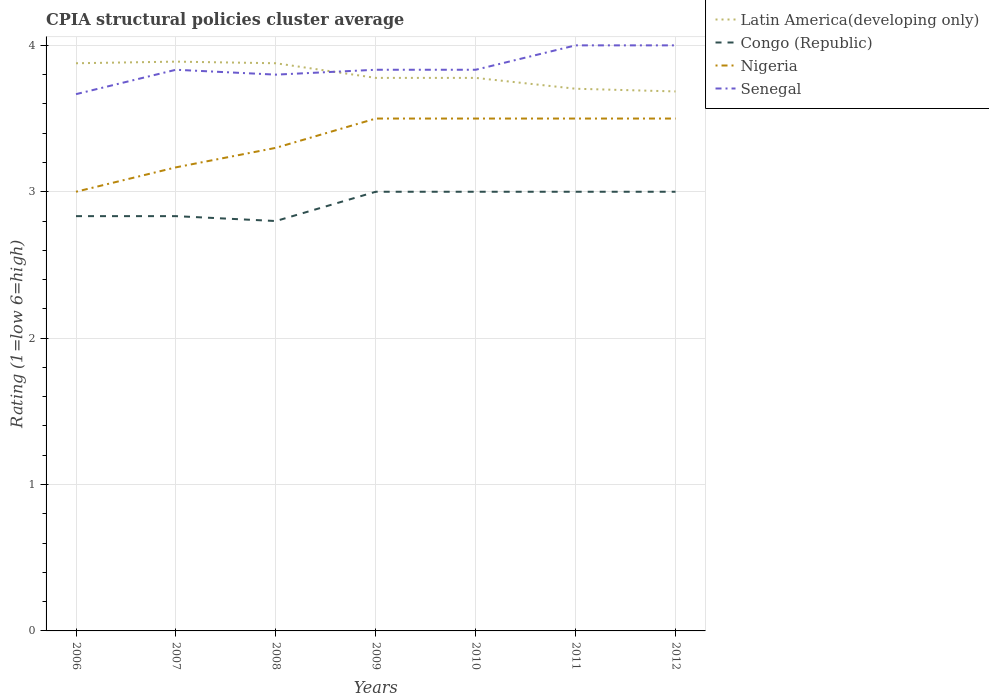How many different coloured lines are there?
Keep it short and to the point. 4. Is the number of lines equal to the number of legend labels?
Your response must be concise. Yes. In which year was the CPIA rating in Congo (Republic) maximum?
Your answer should be compact. 2008. What is the difference between the highest and the second highest CPIA rating in Nigeria?
Your response must be concise. 0.5. What is the difference between the highest and the lowest CPIA rating in Senegal?
Your answer should be very brief. 2. Is the CPIA rating in Senegal strictly greater than the CPIA rating in Nigeria over the years?
Your answer should be compact. No. How many lines are there?
Keep it short and to the point. 4. Does the graph contain any zero values?
Make the answer very short. No. Does the graph contain grids?
Offer a terse response. Yes. Where does the legend appear in the graph?
Keep it short and to the point. Top right. How are the legend labels stacked?
Your response must be concise. Vertical. What is the title of the graph?
Offer a very short reply. CPIA structural policies cluster average. Does "Estonia" appear as one of the legend labels in the graph?
Your response must be concise. No. What is the label or title of the X-axis?
Make the answer very short. Years. What is the label or title of the Y-axis?
Offer a very short reply. Rating (1=low 6=high). What is the Rating (1=low 6=high) of Latin America(developing only) in 2006?
Keep it short and to the point. 3.88. What is the Rating (1=low 6=high) of Congo (Republic) in 2006?
Offer a very short reply. 2.83. What is the Rating (1=low 6=high) of Nigeria in 2006?
Offer a very short reply. 3. What is the Rating (1=low 6=high) of Senegal in 2006?
Offer a terse response. 3.67. What is the Rating (1=low 6=high) of Latin America(developing only) in 2007?
Offer a terse response. 3.89. What is the Rating (1=low 6=high) in Congo (Republic) in 2007?
Offer a very short reply. 2.83. What is the Rating (1=low 6=high) of Nigeria in 2007?
Your response must be concise. 3.17. What is the Rating (1=low 6=high) in Senegal in 2007?
Offer a very short reply. 3.83. What is the Rating (1=low 6=high) of Latin America(developing only) in 2008?
Offer a terse response. 3.88. What is the Rating (1=low 6=high) of Nigeria in 2008?
Give a very brief answer. 3.3. What is the Rating (1=low 6=high) of Latin America(developing only) in 2009?
Provide a succinct answer. 3.78. What is the Rating (1=low 6=high) of Congo (Republic) in 2009?
Ensure brevity in your answer.  3. What is the Rating (1=low 6=high) of Nigeria in 2009?
Provide a short and direct response. 3.5. What is the Rating (1=low 6=high) in Senegal in 2009?
Your response must be concise. 3.83. What is the Rating (1=low 6=high) of Latin America(developing only) in 2010?
Ensure brevity in your answer.  3.78. What is the Rating (1=low 6=high) in Congo (Republic) in 2010?
Ensure brevity in your answer.  3. What is the Rating (1=low 6=high) in Senegal in 2010?
Make the answer very short. 3.83. What is the Rating (1=low 6=high) in Latin America(developing only) in 2011?
Your answer should be compact. 3.7. What is the Rating (1=low 6=high) in Latin America(developing only) in 2012?
Your answer should be compact. 3.69. What is the Rating (1=low 6=high) of Congo (Republic) in 2012?
Keep it short and to the point. 3. What is the Rating (1=low 6=high) in Nigeria in 2012?
Offer a very short reply. 3.5. What is the Rating (1=low 6=high) of Senegal in 2012?
Offer a very short reply. 4. Across all years, what is the maximum Rating (1=low 6=high) of Latin America(developing only)?
Your answer should be very brief. 3.89. Across all years, what is the maximum Rating (1=low 6=high) in Senegal?
Offer a very short reply. 4. Across all years, what is the minimum Rating (1=low 6=high) of Latin America(developing only)?
Your answer should be compact. 3.69. Across all years, what is the minimum Rating (1=low 6=high) of Congo (Republic)?
Your response must be concise. 2.8. Across all years, what is the minimum Rating (1=low 6=high) of Senegal?
Your answer should be very brief. 3.67. What is the total Rating (1=low 6=high) in Latin America(developing only) in the graph?
Make the answer very short. 26.59. What is the total Rating (1=low 6=high) in Congo (Republic) in the graph?
Give a very brief answer. 20.47. What is the total Rating (1=low 6=high) in Nigeria in the graph?
Ensure brevity in your answer.  23.47. What is the total Rating (1=low 6=high) of Senegal in the graph?
Offer a very short reply. 26.97. What is the difference between the Rating (1=low 6=high) of Latin America(developing only) in 2006 and that in 2007?
Keep it short and to the point. -0.01. What is the difference between the Rating (1=low 6=high) of Congo (Republic) in 2006 and that in 2008?
Offer a very short reply. 0.03. What is the difference between the Rating (1=low 6=high) in Nigeria in 2006 and that in 2008?
Your answer should be very brief. -0.3. What is the difference between the Rating (1=low 6=high) of Senegal in 2006 and that in 2008?
Give a very brief answer. -0.13. What is the difference between the Rating (1=low 6=high) in Nigeria in 2006 and that in 2009?
Offer a terse response. -0.5. What is the difference between the Rating (1=low 6=high) of Senegal in 2006 and that in 2009?
Make the answer very short. -0.17. What is the difference between the Rating (1=low 6=high) of Latin America(developing only) in 2006 and that in 2010?
Make the answer very short. 0.1. What is the difference between the Rating (1=low 6=high) in Nigeria in 2006 and that in 2010?
Provide a succinct answer. -0.5. What is the difference between the Rating (1=low 6=high) of Latin America(developing only) in 2006 and that in 2011?
Offer a very short reply. 0.17. What is the difference between the Rating (1=low 6=high) in Congo (Republic) in 2006 and that in 2011?
Keep it short and to the point. -0.17. What is the difference between the Rating (1=low 6=high) in Latin America(developing only) in 2006 and that in 2012?
Offer a very short reply. 0.19. What is the difference between the Rating (1=low 6=high) of Nigeria in 2006 and that in 2012?
Provide a succinct answer. -0.5. What is the difference between the Rating (1=low 6=high) of Latin America(developing only) in 2007 and that in 2008?
Keep it short and to the point. 0.01. What is the difference between the Rating (1=low 6=high) of Congo (Republic) in 2007 and that in 2008?
Ensure brevity in your answer.  0.03. What is the difference between the Rating (1=low 6=high) in Nigeria in 2007 and that in 2008?
Give a very brief answer. -0.13. What is the difference between the Rating (1=low 6=high) in Senegal in 2007 and that in 2008?
Offer a terse response. 0.03. What is the difference between the Rating (1=low 6=high) in Congo (Republic) in 2007 and that in 2009?
Ensure brevity in your answer.  -0.17. What is the difference between the Rating (1=low 6=high) of Nigeria in 2007 and that in 2009?
Keep it short and to the point. -0.33. What is the difference between the Rating (1=low 6=high) of Congo (Republic) in 2007 and that in 2010?
Your answer should be compact. -0.17. What is the difference between the Rating (1=low 6=high) of Latin America(developing only) in 2007 and that in 2011?
Your answer should be compact. 0.19. What is the difference between the Rating (1=low 6=high) in Congo (Republic) in 2007 and that in 2011?
Offer a very short reply. -0.17. What is the difference between the Rating (1=low 6=high) in Senegal in 2007 and that in 2011?
Offer a very short reply. -0.17. What is the difference between the Rating (1=low 6=high) in Latin America(developing only) in 2007 and that in 2012?
Your answer should be compact. 0.2. What is the difference between the Rating (1=low 6=high) of Congo (Republic) in 2007 and that in 2012?
Offer a terse response. -0.17. What is the difference between the Rating (1=low 6=high) of Congo (Republic) in 2008 and that in 2009?
Keep it short and to the point. -0.2. What is the difference between the Rating (1=low 6=high) of Senegal in 2008 and that in 2009?
Give a very brief answer. -0.03. What is the difference between the Rating (1=low 6=high) of Congo (Republic) in 2008 and that in 2010?
Give a very brief answer. -0.2. What is the difference between the Rating (1=low 6=high) in Nigeria in 2008 and that in 2010?
Give a very brief answer. -0.2. What is the difference between the Rating (1=low 6=high) in Senegal in 2008 and that in 2010?
Provide a short and direct response. -0.03. What is the difference between the Rating (1=low 6=high) of Latin America(developing only) in 2008 and that in 2011?
Offer a terse response. 0.17. What is the difference between the Rating (1=low 6=high) in Congo (Republic) in 2008 and that in 2011?
Ensure brevity in your answer.  -0.2. What is the difference between the Rating (1=low 6=high) of Latin America(developing only) in 2008 and that in 2012?
Offer a terse response. 0.19. What is the difference between the Rating (1=low 6=high) in Nigeria in 2008 and that in 2012?
Ensure brevity in your answer.  -0.2. What is the difference between the Rating (1=low 6=high) in Congo (Republic) in 2009 and that in 2010?
Ensure brevity in your answer.  0. What is the difference between the Rating (1=low 6=high) of Nigeria in 2009 and that in 2010?
Your answer should be compact. 0. What is the difference between the Rating (1=low 6=high) in Senegal in 2009 and that in 2010?
Provide a succinct answer. 0. What is the difference between the Rating (1=low 6=high) in Latin America(developing only) in 2009 and that in 2011?
Provide a succinct answer. 0.07. What is the difference between the Rating (1=low 6=high) in Congo (Republic) in 2009 and that in 2011?
Provide a short and direct response. 0. What is the difference between the Rating (1=low 6=high) in Nigeria in 2009 and that in 2011?
Your answer should be compact. 0. What is the difference between the Rating (1=low 6=high) in Latin America(developing only) in 2009 and that in 2012?
Offer a very short reply. 0.09. What is the difference between the Rating (1=low 6=high) in Congo (Republic) in 2009 and that in 2012?
Your response must be concise. 0. What is the difference between the Rating (1=low 6=high) of Nigeria in 2009 and that in 2012?
Offer a terse response. 0. What is the difference between the Rating (1=low 6=high) of Senegal in 2009 and that in 2012?
Your response must be concise. -0.17. What is the difference between the Rating (1=low 6=high) in Latin America(developing only) in 2010 and that in 2011?
Your response must be concise. 0.07. What is the difference between the Rating (1=low 6=high) of Congo (Republic) in 2010 and that in 2011?
Your answer should be compact. 0. What is the difference between the Rating (1=low 6=high) of Nigeria in 2010 and that in 2011?
Give a very brief answer. 0. What is the difference between the Rating (1=low 6=high) of Senegal in 2010 and that in 2011?
Your response must be concise. -0.17. What is the difference between the Rating (1=low 6=high) in Latin America(developing only) in 2010 and that in 2012?
Your answer should be compact. 0.09. What is the difference between the Rating (1=low 6=high) in Nigeria in 2010 and that in 2012?
Keep it short and to the point. 0. What is the difference between the Rating (1=low 6=high) of Senegal in 2010 and that in 2012?
Keep it short and to the point. -0.17. What is the difference between the Rating (1=low 6=high) of Latin America(developing only) in 2011 and that in 2012?
Provide a succinct answer. 0.02. What is the difference between the Rating (1=low 6=high) in Congo (Republic) in 2011 and that in 2012?
Your answer should be very brief. 0. What is the difference between the Rating (1=low 6=high) in Senegal in 2011 and that in 2012?
Your response must be concise. 0. What is the difference between the Rating (1=low 6=high) of Latin America(developing only) in 2006 and the Rating (1=low 6=high) of Congo (Republic) in 2007?
Make the answer very short. 1.04. What is the difference between the Rating (1=low 6=high) in Latin America(developing only) in 2006 and the Rating (1=low 6=high) in Nigeria in 2007?
Provide a short and direct response. 0.71. What is the difference between the Rating (1=low 6=high) in Latin America(developing only) in 2006 and the Rating (1=low 6=high) in Senegal in 2007?
Ensure brevity in your answer.  0.04. What is the difference between the Rating (1=low 6=high) in Congo (Republic) in 2006 and the Rating (1=low 6=high) in Senegal in 2007?
Your answer should be compact. -1. What is the difference between the Rating (1=low 6=high) in Latin America(developing only) in 2006 and the Rating (1=low 6=high) in Congo (Republic) in 2008?
Provide a succinct answer. 1.08. What is the difference between the Rating (1=low 6=high) of Latin America(developing only) in 2006 and the Rating (1=low 6=high) of Nigeria in 2008?
Your answer should be compact. 0.58. What is the difference between the Rating (1=low 6=high) in Latin America(developing only) in 2006 and the Rating (1=low 6=high) in Senegal in 2008?
Offer a very short reply. 0.08. What is the difference between the Rating (1=low 6=high) in Congo (Republic) in 2006 and the Rating (1=low 6=high) in Nigeria in 2008?
Make the answer very short. -0.47. What is the difference between the Rating (1=low 6=high) in Congo (Republic) in 2006 and the Rating (1=low 6=high) in Senegal in 2008?
Your answer should be compact. -0.97. What is the difference between the Rating (1=low 6=high) of Nigeria in 2006 and the Rating (1=low 6=high) of Senegal in 2008?
Your answer should be compact. -0.8. What is the difference between the Rating (1=low 6=high) in Latin America(developing only) in 2006 and the Rating (1=low 6=high) in Congo (Republic) in 2009?
Offer a terse response. 0.88. What is the difference between the Rating (1=low 6=high) in Latin America(developing only) in 2006 and the Rating (1=low 6=high) in Nigeria in 2009?
Offer a very short reply. 0.38. What is the difference between the Rating (1=low 6=high) in Latin America(developing only) in 2006 and the Rating (1=low 6=high) in Senegal in 2009?
Give a very brief answer. 0.04. What is the difference between the Rating (1=low 6=high) in Nigeria in 2006 and the Rating (1=low 6=high) in Senegal in 2009?
Provide a short and direct response. -0.83. What is the difference between the Rating (1=low 6=high) of Latin America(developing only) in 2006 and the Rating (1=low 6=high) of Congo (Republic) in 2010?
Keep it short and to the point. 0.88. What is the difference between the Rating (1=low 6=high) of Latin America(developing only) in 2006 and the Rating (1=low 6=high) of Nigeria in 2010?
Give a very brief answer. 0.38. What is the difference between the Rating (1=low 6=high) of Latin America(developing only) in 2006 and the Rating (1=low 6=high) of Senegal in 2010?
Make the answer very short. 0.04. What is the difference between the Rating (1=low 6=high) in Congo (Republic) in 2006 and the Rating (1=low 6=high) in Senegal in 2010?
Offer a terse response. -1. What is the difference between the Rating (1=low 6=high) in Nigeria in 2006 and the Rating (1=low 6=high) in Senegal in 2010?
Offer a terse response. -0.83. What is the difference between the Rating (1=low 6=high) of Latin America(developing only) in 2006 and the Rating (1=low 6=high) of Congo (Republic) in 2011?
Ensure brevity in your answer.  0.88. What is the difference between the Rating (1=low 6=high) in Latin America(developing only) in 2006 and the Rating (1=low 6=high) in Nigeria in 2011?
Keep it short and to the point. 0.38. What is the difference between the Rating (1=low 6=high) of Latin America(developing only) in 2006 and the Rating (1=low 6=high) of Senegal in 2011?
Your answer should be compact. -0.12. What is the difference between the Rating (1=low 6=high) of Congo (Republic) in 2006 and the Rating (1=low 6=high) of Senegal in 2011?
Provide a succinct answer. -1.17. What is the difference between the Rating (1=low 6=high) of Latin America(developing only) in 2006 and the Rating (1=low 6=high) of Congo (Republic) in 2012?
Provide a short and direct response. 0.88. What is the difference between the Rating (1=low 6=high) of Latin America(developing only) in 2006 and the Rating (1=low 6=high) of Nigeria in 2012?
Your response must be concise. 0.38. What is the difference between the Rating (1=low 6=high) in Latin America(developing only) in 2006 and the Rating (1=low 6=high) in Senegal in 2012?
Make the answer very short. -0.12. What is the difference between the Rating (1=low 6=high) of Congo (Republic) in 2006 and the Rating (1=low 6=high) of Senegal in 2012?
Keep it short and to the point. -1.17. What is the difference between the Rating (1=low 6=high) in Nigeria in 2006 and the Rating (1=low 6=high) in Senegal in 2012?
Ensure brevity in your answer.  -1. What is the difference between the Rating (1=low 6=high) in Latin America(developing only) in 2007 and the Rating (1=low 6=high) in Congo (Republic) in 2008?
Provide a short and direct response. 1.09. What is the difference between the Rating (1=low 6=high) of Latin America(developing only) in 2007 and the Rating (1=low 6=high) of Nigeria in 2008?
Ensure brevity in your answer.  0.59. What is the difference between the Rating (1=low 6=high) of Latin America(developing only) in 2007 and the Rating (1=low 6=high) of Senegal in 2008?
Make the answer very short. 0.09. What is the difference between the Rating (1=low 6=high) of Congo (Republic) in 2007 and the Rating (1=low 6=high) of Nigeria in 2008?
Your answer should be very brief. -0.47. What is the difference between the Rating (1=low 6=high) of Congo (Republic) in 2007 and the Rating (1=low 6=high) of Senegal in 2008?
Make the answer very short. -0.97. What is the difference between the Rating (1=low 6=high) of Nigeria in 2007 and the Rating (1=low 6=high) of Senegal in 2008?
Ensure brevity in your answer.  -0.63. What is the difference between the Rating (1=low 6=high) in Latin America(developing only) in 2007 and the Rating (1=low 6=high) in Congo (Republic) in 2009?
Make the answer very short. 0.89. What is the difference between the Rating (1=low 6=high) in Latin America(developing only) in 2007 and the Rating (1=low 6=high) in Nigeria in 2009?
Your answer should be compact. 0.39. What is the difference between the Rating (1=low 6=high) in Latin America(developing only) in 2007 and the Rating (1=low 6=high) in Senegal in 2009?
Give a very brief answer. 0.06. What is the difference between the Rating (1=low 6=high) of Latin America(developing only) in 2007 and the Rating (1=low 6=high) of Nigeria in 2010?
Provide a succinct answer. 0.39. What is the difference between the Rating (1=low 6=high) in Latin America(developing only) in 2007 and the Rating (1=low 6=high) in Senegal in 2010?
Ensure brevity in your answer.  0.06. What is the difference between the Rating (1=low 6=high) of Congo (Republic) in 2007 and the Rating (1=low 6=high) of Nigeria in 2010?
Keep it short and to the point. -0.67. What is the difference between the Rating (1=low 6=high) in Congo (Republic) in 2007 and the Rating (1=low 6=high) in Senegal in 2010?
Make the answer very short. -1. What is the difference between the Rating (1=low 6=high) of Latin America(developing only) in 2007 and the Rating (1=low 6=high) of Congo (Republic) in 2011?
Make the answer very short. 0.89. What is the difference between the Rating (1=low 6=high) in Latin America(developing only) in 2007 and the Rating (1=low 6=high) in Nigeria in 2011?
Keep it short and to the point. 0.39. What is the difference between the Rating (1=low 6=high) in Latin America(developing only) in 2007 and the Rating (1=low 6=high) in Senegal in 2011?
Make the answer very short. -0.11. What is the difference between the Rating (1=low 6=high) in Congo (Republic) in 2007 and the Rating (1=low 6=high) in Senegal in 2011?
Your response must be concise. -1.17. What is the difference between the Rating (1=low 6=high) of Nigeria in 2007 and the Rating (1=low 6=high) of Senegal in 2011?
Provide a short and direct response. -0.83. What is the difference between the Rating (1=low 6=high) of Latin America(developing only) in 2007 and the Rating (1=low 6=high) of Nigeria in 2012?
Your response must be concise. 0.39. What is the difference between the Rating (1=low 6=high) of Latin America(developing only) in 2007 and the Rating (1=low 6=high) of Senegal in 2012?
Make the answer very short. -0.11. What is the difference between the Rating (1=low 6=high) of Congo (Republic) in 2007 and the Rating (1=low 6=high) of Senegal in 2012?
Make the answer very short. -1.17. What is the difference between the Rating (1=low 6=high) in Latin America(developing only) in 2008 and the Rating (1=low 6=high) in Congo (Republic) in 2009?
Provide a short and direct response. 0.88. What is the difference between the Rating (1=low 6=high) in Latin America(developing only) in 2008 and the Rating (1=low 6=high) in Nigeria in 2009?
Make the answer very short. 0.38. What is the difference between the Rating (1=low 6=high) in Latin America(developing only) in 2008 and the Rating (1=low 6=high) in Senegal in 2009?
Provide a short and direct response. 0.04. What is the difference between the Rating (1=low 6=high) in Congo (Republic) in 2008 and the Rating (1=low 6=high) in Senegal in 2009?
Make the answer very short. -1.03. What is the difference between the Rating (1=low 6=high) in Nigeria in 2008 and the Rating (1=low 6=high) in Senegal in 2009?
Provide a short and direct response. -0.53. What is the difference between the Rating (1=low 6=high) of Latin America(developing only) in 2008 and the Rating (1=low 6=high) of Congo (Republic) in 2010?
Make the answer very short. 0.88. What is the difference between the Rating (1=low 6=high) of Latin America(developing only) in 2008 and the Rating (1=low 6=high) of Nigeria in 2010?
Your answer should be compact. 0.38. What is the difference between the Rating (1=low 6=high) in Latin America(developing only) in 2008 and the Rating (1=low 6=high) in Senegal in 2010?
Make the answer very short. 0.04. What is the difference between the Rating (1=low 6=high) in Congo (Republic) in 2008 and the Rating (1=low 6=high) in Nigeria in 2010?
Ensure brevity in your answer.  -0.7. What is the difference between the Rating (1=low 6=high) in Congo (Republic) in 2008 and the Rating (1=low 6=high) in Senegal in 2010?
Your response must be concise. -1.03. What is the difference between the Rating (1=low 6=high) in Nigeria in 2008 and the Rating (1=low 6=high) in Senegal in 2010?
Provide a short and direct response. -0.53. What is the difference between the Rating (1=low 6=high) of Latin America(developing only) in 2008 and the Rating (1=low 6=high) of Congo (Republic) in 2011?
Keep it short and to the point. 0.88. What is the difference between the Rating (1=low 6=high) in Latin America(developing only) in 2008 and the Rating (1=low 6=high) in Nigeria in 2011?
Offer a very short reply. 0.38. What is the difference between the Rating (1=low 6=high) in Latin America(developing only) in 2008 and the Rating (1=low 6=high) in Senegal in 2011?
Offer a terse response. -0.12. What is the difference between the Rating (1=low 6=high) in Congo (Republic) in 2008 and the Rating (1=low 6=high) in Senegal in 2011?
Your answer should be very brief. -1.2. What is the difference between the Rating (1=low 6=high) in Nigeria in 2008 and the Rating (1=low 6=high) in Senegal in 2011?
Provide a short and direct response. -0.7. What is the difference between the Rating (1=low 6=high) of Latin America(developing only) in 2008 and the Rating (1=low 6=high) of Congo (Republic) in 2012?
Provide a succinct answer. 0.88. What is the difference between the Rating (1=low 6=high) in Latin America(developing only) in 2008 and the Rating (1=low 6=high) in Nigeria in 2012?
Your answer should be compact. 0.38. What is the difference between the Rating (1=low 6=high) in Latin America(developing only) in 2008 and the Rating (1=low 6=high) in Senegal in 2012?
Make the answer very short. -0.12. What is the difference between the Rating (1=low 6=high) of Congo (Republic) in 2008 and the Rating (1=low 6=high) of Nigeria in 2012?
Your answer should be compact. -0.7. What is the difference between the Rating (1=low 6=high) in Congo (Republic) in 2008 and the Rating (1=low 6=high) in Senegal in 2012?
Your response must be concise. -1.2. What is the difference between the Rating (1=low 6=high) of Nigeria in 2008 and the Rating (1=low 6=high) of Senegal in 2012?
Provide a succinct answer. -0.7. What is the difference between the Rating (1=low 6=high) in Latin America(developing only) in 2009 and the Rating (1=low 6=high) in Nigeria in 2010?
Offer a terse response. 0.28. What is the difference between the Rating (1=low 6=high) in Latin America(developing only) in 2009 and the Rating (1=low 6=high) in Senegal in 2010?
Provide a short and direct response. -0.06. What is the difference between the Rating (1=low 6=high) in Congo (Republic) in 2009 and the Rating (1=low 6=high) in Senegal in 2010?
Your answer should be very brief. -0.83. What is the difference between the Rating (1=low 6=high) of Latin America(developing only) in 2009 and the Rating (1=low 6=high) of Congo (Republic) in 2011?
Make the answer very short. 0.78. What is the difference between the Rating (1=low 6=high) in Latin America(developing only) in 2009 and the Rating (1=low 6=high) in Nigeria in 2011?
Offer a terse response. 0.28. What is the difference between the Rating (1=low 6=high) in Latin America(developing only) in 2009 and the Rating (1=low 6=high) in Senegal in 2011?
Give a very brief answer. -0.22. What is the difference between the Rating (1=low 6=high) in Congo (Republic) in 2009 and the Rating (1=low 6=high) in Senegal in 2011?
Your answer should be compact. -1. What is the difference between the Rating (1=low 6=high) in Latin America(developing only) in 2009 and the Rating (1=low 6=high) in Congo (Republic) in 2012?
Ensure brevity in your answer.  0.78. What is the difference between the Rating (1=low 6=high) of Latin America(developing only) in 2009 and the Rating (1=low 6=high) of Nigeria in 2012?
Provide a succinct answer. 0.28. What is the difference between the Rating (1=low 6=high) in Latin America(developing only) in 2009 and the Rating (1=low 6=high) in Senegal in 2012?
Give a very brief answer. -0.22. What is the difference between the Rating (1=low 6=high) in Congo (Republic) in 2009 and the Rating (1=low 6=high) in Senegal in 2012?
Make the answer very short. -1. What is the difference between the Rating (1=low 6=high) of Latin America(developing only) in 2010 and the Rating (1=low 6=high) of Nigeria in 2011?
Offer a terse response. 0.28. What is the difference between the Rating (1=low 6=high) of Latin America(developing only) in 2010 and the Rating (1=low 6=high) of Senegal in 2011?
Your answer should be very brief. -0.22. What is the difference between the Rating (1=low 6=high) of Latin America(developing only) in 2010 and the Rating (1=low 6=high) of Congo (Republic) in 2012?
Provide a short and direct response. 0.78. What is the difference between the Rating (1=low 6=high) of Latin America(developing only) in 2010 and the Rating (1=low 6=high) of Nigeria in 2012?
Offer a terse response. 0.28. What is the difference between the Rating (1=low 6=high) in Latin America(developing only) in 2010 and the Rating (1=low 6=high) in Senegal in 2012?
Your answer should be compact. -0.22. What is the difference between the Rating (1=low 6=high) of Congo (Republic) in 2010 and the Rating (1=low 6=high) of Nigeria in 2012?
Your response must be concise. -0.5. What is the difference between the Rating (1=low 6=high) in Nigeria in 2010 and the Rating (1=low 6=high) in Senegal in 2012?
Your answer should be very brief. -0.5. What is the difference between the Rating (1=low 6=high) in Latin America(developing only) in 2011 and the Rating (1=low 6=high) in Congo (Republic) in 2012?
Give a very brief answer. 0.7. What is the difference between the Rating (1=low 6=high) in Latin America(developing only) in 2011 and the Rating (1=low 6=high) in Nigeria in 2012?
Give a very brief answer. 0.2. What is the difference between the Rating (1=low 6=high) of Latin America(developing only) in 2011 and the Rating (1=low 6=high) of Senegal in 2012?
Your answer should be very brief. -0.3. What is the difference between the Rating (1=low 6=high) of Congo (Republic) in 2011 and the Rating (1=low 6=high) of Nigeria in 2012?
Your answer should be very brief. -0.5. What is the average Rating (1=low 6=high) of Latin America(developing only) per year?
Your answer should be very brief. 3.8. What is the average Rating (1=low 6=high) in Congo (Republic) per year?
Provide a short and direct response. 2.92. What is the average Rating (1=low 6=high) of Nigeria per year?
Ensure brevity in your answer.  3.35. What is the average Rating (1=low 6=high) of Senegal per year?
Provide a short and direct response. 3.85. In the year 2006, what is the difference between the Rating (1=low 6=high) of Latin America(developing only) and Rating (1=low 6=high) of Congo (Republic)?
Provide a succinct answer. 1.04. In the year 2006, what is the difference between the Rating (1=low 6=high) in Latin America(developing only) and Rating (1=low 6=high) in Nigeria?
Offer a terse response. 0.88. In the year 2006, what is the difference between the Rating (1=low 6=high) of Latin America(developing only) and Rating (1=low 6=high) of Senegal?
Provide a succinct answer. 0.21. In the year 2006, what is the difference between the Rating (1=low 6=high) of Congo (Republic) and Rating (1=low 6=high) of Nigeria?
Your answer should be compact. -0.17. In the year 2007, what is the difference between the Rating (1=low 6=high) of Latin America(developing only) and Rating (1=low 6=high) of Congo (Republic)?
Provide a succinct answer. 1.06. In the year 2007, what is the difference between the Rating (1=low 6=high) of Latin America(developing only) and Rating (1=low 6=high) of Nigeria?
Provide a short and direct response. 0.72. In the year 2007, what is the difference between the Rating (1=low 6=high) of Latin America(developing only) and Rating (1=low 6=high) of Senegal?
Give a very brief answer. 0.06. In the year 2007, what is the difference between the Rating (1=low 6=high) in Nigeria and Rating (1=low 6=high) in Senegal?
Offer a terse response. -0.67. In the year 2008, what is the difference between the Rating (1=low 6=high) of Latin America(developing only) and Rating (1=low 6=high) of Congo (Republic)?
Make the answer very short. 1.08. In the year 2008, what is the difference between the Rating (1=low 6=high) in Latin America(developing only) and Rating (1=low 6=high) in Nigeria?
Provide a succinct answer. 0.58. In the year 2008, what is the difference between the Rating (1=low 6=high) of Latin America(developing only) and Rating (1=low 6=high) of Senegal?
Provide a short and direct response. 0.08. In the year 2008, what is the difference between the Rating (1=low 6=high) of Nigeria and Rating (1=low 6=high) of Senegal?
Your answer should be very brief. -0.5. In the year 2009, what is the difference between the Rating (1=low 6=high) in Latin America(developing only) and Rating (1=low 6=high) in Congo (Republic)?
Your answer should be very brief. 0.78. In the year 2009, what is the difference between the Rating (1=low 6=high) in Latin America(developing only) and Rating (1=low 6=high) in Nigeria?
Provide a short and direct response. 0.28. In the year 2009, what is the difference between the Rating (1=low 6=high) of Latin America(developing only) and Rating (1=low 6=high) of Senegal?
Provide a succinct answer. -0.06. In the year 2009, what is the difference between the Rating (1=low 6=high) in Congo (Republic) and Rating (1=low 6=high) in Senegal?
Ensure brevity in your answer.  -0.83. In the year 2010, what is the difference between the Rating (1=low 6=high) of Latin America(developing only) and Rating (1=low 6=high) of Congo (Republic)?
Offer a very short reply. 0.78. In the year 2010, what is the difference between the Rating (1=low 6=high) in Latin America(developing only) and Rating (1=low 6=high) in Nigeria?
Provide a short and direct response. 0.28. In the year 2010, what is the difference between the Rating (1=low 6=high) of Latin America(developing only) and Rating (1=low 6=high) of Senegal?
Offer a terse response. -0.06. In the year 2010, what is the difference between the Rating (1=low 6=high) of Congo (Republic) and Rating (1=low 6=high) of Nigeria?
Make the answer very short. -0.5. In the year 2010, what is the difference between the Rating (1=low 6=high) of Congo (Republic) and Rating (1=low 6=high) of Senegal?
Offer a terse response. -0.83. In the year 2011, what is the difference between the Rating (1=low 6=high) of Latin America(developing only) and Rating (1=low 6=high) of Congo (Republic)?
Ensure brevity in your answer.  0.7. In the year 2011, what is the difference between the Rating (1=low 6=high) of Latin America(developing only) and Rating (1=low 6=high) of Nigeria?
Your answer should be compact. 0.2. In the year 2011, what is the difference between the Rating (1=low 6=high) of Latin America(developing only) and Rating (1=low 6=high) of Senegal?
Make the answer very short. -0.3. In the year 2012, what is the difference between the Rating (1=low 6=high) of Latin America(developing only) and Rating (1=low 6=high) of Congo (Republic)?
Your answer should be very brief. 0.69. In the year 2012, what is the difference between the Rating (1=low 6=high) in Latin America(developing only) and Rating (1=low 6=high) in Nigeria?
Provide a succinct answer. 0.19. In the year 2012, what is the difference between the Rating (1=low 6=high) of Latin America(developing only) and Rating (1=low 6=high) of Senegal?
Your answer should be very brief. -0.31. What is the ratio of the Rating (1=low 6=high) in Latin America(developing only) in 2006 to that in 2007?
Make the answer very short. 1. What is the ratio of the Rating (1=low 6=high) in Senegal in 2006 to that in 2007?
Offer a terse response. 0.96. What is the ratio of the Rating (1=low 6=high) of Latin America(developing only) in 2006 to that in 2008?
Make the answer very short. 1. What is the ratio of the Rating (1=low 6=high) of Congo (Republic) in 2006 to that in 2008?
Give a very brief answer. 1.01. What is the ratio of the Rating (1=low 6=high) in Nigeria in 2006 to that in 2008?
Make the answer very short. 0.91. What is the ratio of the Rating (1=low 6=high) in Senegal in 2006 to that in 2008?
Ensure brevity in your answer.  0.96. What is the ratio of the Rating (1=low 6=high) in Latin America(developing only) in 2006 to that in 2009?
Keep it short and to the point. 1.03. What is the ratio of the Rating (1=low 6=high) in Senegal in 2006 to that in 2009?
Your answer should be compact. 0.96. What is the ratio of the Rating (1=low 6=high) in Latin America(developing only) in 2006 to that in 2010?
Give a very brief answer. 1.03. What is the ratio of the Rating (1=low 6=high) in Congo (Republic) in 2006 to that in 2010?
Keep it short and to the point. 0.94. What is the ratio of the Rating (1=low 6=high) of Senegal in 2006 to that in 2010?
Your answer should be very brief. 0.96. What is the ratio of the Rating (1=low 6=high) in Latin America(developing only) in 2006 to that in 2011?
Provide a short and direct response. 1.05. What is the ratio of the Rating (1=low 6=high) in Congo (Republic) in 2006 to that in 2011?
Ensure brevity in your answer.  0.94. What is the ratio of the Rating (1=low 6=high) of Senegal in 2006 to that in 2011?
Your answer should be compact. 0.92. What is the ratio of the Rating (1=low 6=high) of Latin America(developing only) in 2006 to that in 2012?
Provide a succinct answer. 1.05. What is the ratio of the Rating (1=low 6=high) in Latin America(developing only) in 2007 to that in 2008?
Ensure brevity in your answer.  1. What is the ratio of the Rating (1=low 6=high) of Congo (Republic) in 2007 to that in 2008?
Offer a very short reply. 1.01. What is the ratio of the Rating (1=low 6=high) of Nigeria in 2007 to that in 2008?
Your answer should be very brief. 0.96. What is the ratio of the Rating (1=low 6=high) of Senegal in 2007 to that in 2008?
Your response must be concise. 1.01. What is the ratio of the Rating (1=low 6=high) of Latin America(developing only) in 2007 to that in 2009?
Offer a terse response. 1.03. What is the ratio of the Rating (1=low 6=high) of Nigeria in 2007 to that in 2009?
Provide a short and direct response. 0.9. What is the ratio of the Rating (1=low 6=high) of Senegal in 2007 to that in 2009?
Make the answer very short. 1. What is the ratio of the Rating (1=low 6=high) of Latin America(developing only) in 2007 to that in 2010?
Provide a short and direct response. 1.03. What is the ratio of the Rating (1=low 6=high) of Nigeria in 2007 to that in 2010?
Give a very brief answer. 0.9. What is the ratio of the Rating (1=low 6=high) of Senegal in 2007 to that in 2010?
Your response must be concise. 1. What is the ratio of the Rating (1=low 6=high) of Nigeria in 2007 to that in 2011?
Keep it short and to the point. 0.9. What is the ratio of the Rating (1=low 6=high) in Senegal in 2007 to that in 2011?
Your response must be concise. 0.96. What is the ratio of the Rating (1=low 6=high) in Latin America(developing only) in 2007 to that in 2012?
Offer a terse response. 1.06. What is the ratio of the Rating (1=low 6=high) of Nigeria in 2007 to that in 2012?
Your answer should be compact. 0.9. What is the ratio of the Rating (1=low 6=high) of Senegal in 2007 to that in 2012?
Offer a terse response. 0.96. What is the ratio of the Rating (1=low 6=high) of Latin America(developing only) in 2008 to that in 2009?
Your answer should be compact. 1.03. What is the ratio of the Rating (1=low 6=high) of Nigeria in 2008 to that in 2009?
Provide a short and direct response. 0.94. What is the ratio of the Rating (1=low 6=high) in Latin America(developing only) in 2008 to that in 2010?
Provide a succinct answer. 1.03. What is the ratio of the Rating (1=low 6=high) of Congo (Republic) in 2008 to that in 2010?
Your answer should be very brief. 0.93. What is the ratio of the Rating (1=low 6=high) of Nigeria in 2008 to that in 2010?
Offer a terse response. 0.94. What is the ratio of the Rating (1=low 6=high) of Latin America(developing only) in 2008 to that in 2011?
Provide a short and direct response. 1.05. What is the ratio of the Rating (1=low 6=high) of Congo (Republic) in 2008 to that in 2011?
Provide a short and direct response. 0.93. What is the ratio of the Rating (1=low 6=high) of Nigeria in 2008 to that in 2011?
Offer a terse response. 0.94. What is the ratio of the Rating (1=low 6=high) of Senegal in 2008 to that in 2011?
Provide a short and direct response. 0.95. What is the ratio of the Rating (1=low 6=high) of Latin America(developing only) in 2008 to that in 2012?
Keep it short and to the point. 1.05. What is the ratio of the Rating (1=low 6=high) of Nigeria in 2008 to that in 2012?
Give a very brief answer. 0.94. What is the ratio of the Rating (1=low 6=high) of Senegal in 2008 to that in 2012?
Ensure brevity in your answer.  0.95. What is the ratio of the Rating (1=low 6=high) of Congo (Republic) in 2009 to that in 2010?
Provide a short and direct response. 1. What is the ratio of the Rating (1=low 6=high) of Nigeria in 2009 to that in 2010?
Provide a succinct answer. 1. What is the ratio of the Rating (1=low 6=high) of Nigeria in 2009 to that in 2011?
Ensure brevity in your answer.  1. What is the ratio of the Rating (1=low 6=high) in Senegal in 2009 to that in 2011?
Your answer should be very brief. 0.96. What is the ratio of the Rating (1=low 6=high) of Latin America(developing only) in 2009 to that in 2012?
Make the answer very short. 1.03. What is the ratio of the Rating (1=low 6=high) of Congo (Republic) in 2009 to that in 2012?
Ensure brevity in your answer.  1. What is the ratio of the Rating (1=low 6=high) in Nigeria in 2009 to that in 2012?
Make the answer very short. 1. What is the ratio of the Rating (1=low 6=high) in Latin America(developing only) in 2010 to that in 2011?
Keep it short and to the point. 1.02. What is the ratio of the Rating (1=low 6=high) in Senegal in 2010 to that in 2011?
Offer a terse response. 0.96. What is the ratio of the Rating (1=low 6=high) of Latin America(developing only) in 2010 to that in 2012?
Ensure brevity in your answer.  1.03. What is the ratio of the Rating (1=low 6=high) in Senegal in 2010 to that in 2012?
Your response must be concise. 0.96. What is the ratio of the Rating (1=low 6=high) of Latin America(developing only) in 2011 to that in 2012?
Your answer should be very brief. 1. What is the ratio of the Rating (1=low 6=high) in Senegal in 2011 to that in 2012?
Make the answer very short. 1. What is the difference between the highest and the second highest Rating (1=low 6=high) in Latin America(developing only)?
Ensure brevity in your answer.  0.01. What is the difference between the highest and the lowest Rating (1=low 6=high) of Latin America(developing only)?
Ensure brevity in your answer.  0.2. What is the difference between the highest and the lowest Rating (1=low 6=high) in Congo (Republic)?
Your answer should be very brief. 0.2. What is the difference between the highest and the lowest Rating (1=low 6=high) in Nigeria?
Provide a succinct answer. 0.5. What is the difference between the highest and the lowest Rating (1=low 6=high) in Senegal?
Give a very brief answer. 0.33. 